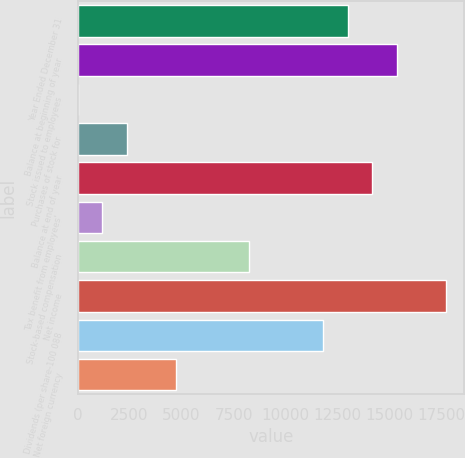Convert chart. <chart><loc_0><loc_0><loc_500><loc_500><bar_chart><fcel>Year Ended December 31<fcel>Balance at beginning of year<fcel>Stock issued to employees<fcel>Purchases of stock for<fcel>Balance at end of year<fcel>Tax benefit from employees'<fcel>Stock-based compensation<fcel>Net income<fcel>Dividends (per share-100 088<fcel>Net foreign currency<nl><fcel>12979.7<fcel>15339.1<fcel>3<fcel>2362.4<fcel>14159.4<fcel>1182.7<fcel>8260.9<fcel>17698.5<fcel>11800<fcel>4721.8<nl></chart> 